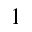Convert formula to latex. <formula><loc_0><loc_0><loc_500><loc_500>1</formula> 